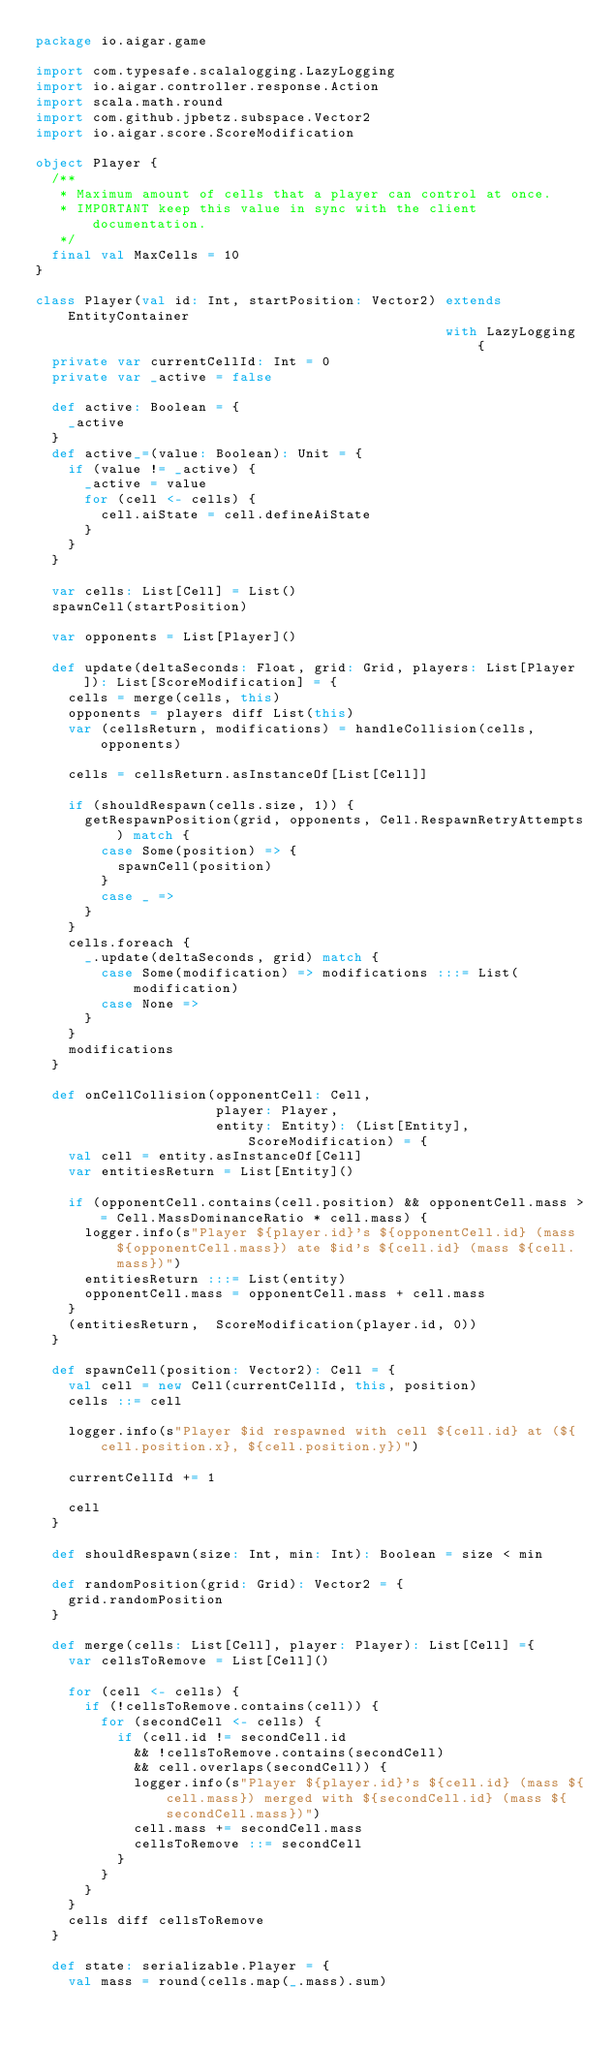<code> <loc_0><loc_0><loc_500><loc_500><_Scala_>package io.aigar.game

import com.typesafe.scalalogging.LazyLogging
import io.aigar.controller.response.Action
import scala.math.round
import com.github.jpbetz.subspace.Vector2
import io.aigar.score.ScoreModification

object Player {
  /**
   * Maximum amount of cells that a player can control at once.
   * IMPORTANT keep this value in sync with the client documentation.
   */
  final val MaxCells = 10
}

class Player(val id: Int, startPosition: Vector2) extends EntityContainer
                                                  with LazyLogging {
  private var currentCellId: Int = 0
  private var _active = false

  def active: Boolean = {
    _active
  }
  def active_=(value: Boolean): Unit = {
    if (value != _active) {
      _active = value
      for (cell <- cells) {
        cell.aiState = cell.defineAiState
      }
    }
  }

  var cells: List[Cell] = List()
  spawnCell(startPosition)

  var opponents = List[Player]()

  def update(deltaSeconds: Float, grid: Grid, players: List[Player]): List[ScoreModification] = {
    cells = merge(cells, this)
    opponents = players diff List(this)
    var (cellsReturn, modifications) = handleCollision(cells, opponents)

    cells = cellsReturn.asInstanceOf[List[Cell]]

    if (shouldRespawn(cells.size, 1)) {
      getRespawnPosition(grid, opponents, Cell.RespawnRetryAttempts) match {
        case Some(position) => {
          spawnCell(position)
        }
        case _ =>
      }
    }
    cells.foreach {
      _.update(deltaSeconds, grid) match {
        case Some(modification) => modifications :::= List(modification)
        case None =>
      }
    }
    modifications
  }

  def onCellCollision(opponentCell: Cell,
                      player: Player,
                      entity: Entity): (List[Entity], ScoreModification) = {
    val cell = entity.asInstanceOf[Cell]
    var entitiesReturn = List[Entity]()

    if (opponentCell.contains(cell.position) && opponentCell.mass >= Cell.MassDominanceRatio * cell.mass) {
      logger.info(s"Player ${player.id}'s ${opponentCell.id} (mass ${opponentCell.mass}) ate $id's ${cell.id} (mass ${cell.mass})")
      entitiesReturn :::= List(entity)
      opponentCell.mass = opponentCell.mass + cell.mass
    }
    (entitiesReturn,  ScoreModification(player.id, 0))
  }

  def spawnCell(position: Vector2): Cell = {
    val cell = new Cell(currentCellId, this, position)
    cells ::= cell

    logger.info(s"Player $id respawned with cell ${cell.id} at (${cell.position.x}, ${cell.position.y})")

    currentCellId += 1

    cell
  }

  def shouldRespawn(size: Int, min: Int): Boolean = size < min

  def randomPosition(grid: Grid): Vector2 = {
    grid.randomPosition
  }

  def merge(cells: List[Cell], player: Player): List[Cell] ={
    var cellsToRemove = List[Cell]()

    for (cell <- cells) {
      if (!cellsToRemove.contains(cell)) {
        for (secondCell <- cells) {
          if (cell.id != secondCell.id
            && !cellsToRemove.contains(secondCell)
            && cell.overlaps(secondCell)) {
            logger.info(s"Player ${player.id}'s ${cell.id} (mass ${cell.mass}) merged with ${secondCell.id} (mass ${secondCell.mass})")
            cell.mass += secondCell.mass
            cellsToRemove ::= secondCell
          }
        }
      }
    }
    cells diff cellsToRemove
  }

  def state: serializable.Player = {
    val mass = round(cells.map(_.mass).sum)</code> 